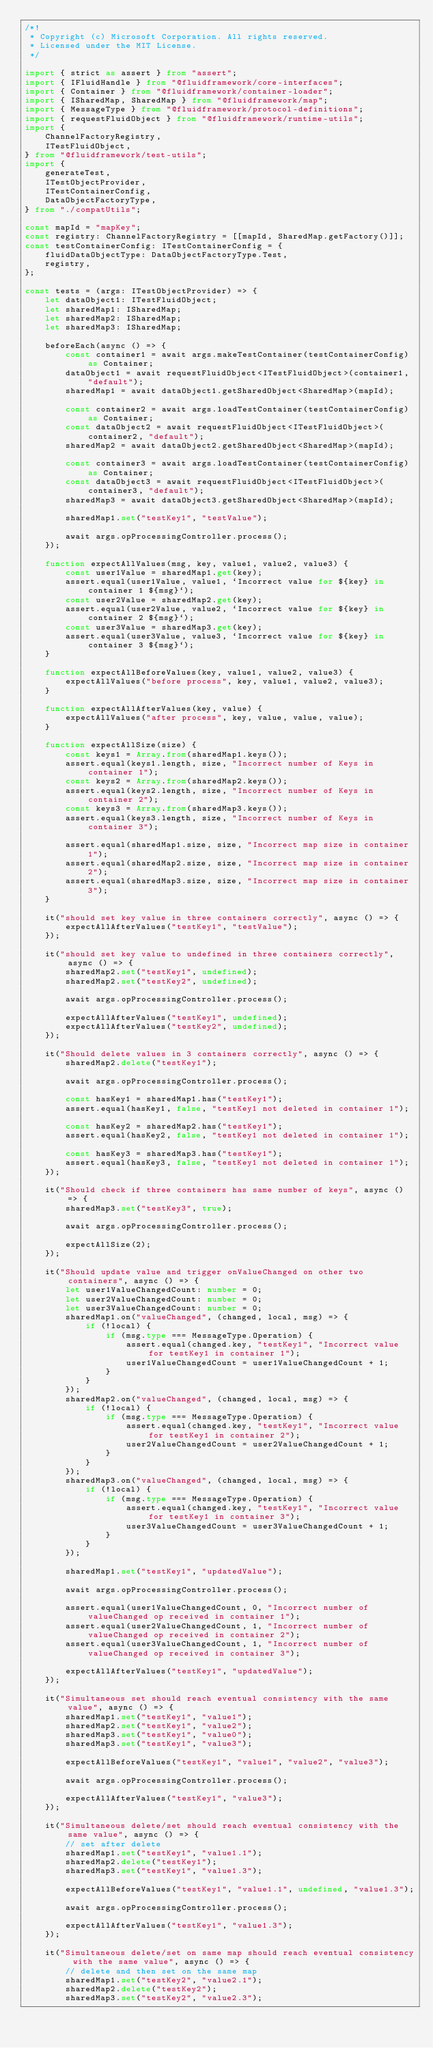Convert code to text. <code><loc_0><loc_0><loc_500><loc_500><_TypeScript_>/*!
 * Copyright (c) Microsoft Corporation. All rights reserved.
 * Licensed under the MIT License.
 */

import { strict as assert } from "assert";
import { IFluidHandle } from "@fluidframework/core-interfaces";
import { Container } from "@fluidframework/container-loader";
import { ISharedMap, SharedMap } from "@fluidframework/map";
import { MessageType } from "@fluidframework/protocol-definitions";
import { requestFluidObject } from "@fluidframework/runtime-utils";
import {
    ChannelFactoryRegistry,
    ITestFluidObject,
} from "@fluidframework/test-utils";
import {
    generateTest,
    ITestObjectProvider,
    ITestContainerConfig,
    DataObjectFactoryType,
} from "./compatUtils";

const mapId = "mapKey";
const registry: ChannelFactoryRegistry = [[mapId, SharedMap.getFactory()]];
const testContainerConfig: ITestContainerConfig = {
    fluidDataObjectType: DataObjectFactoryType.Test,
    registry,
};

const tests = (args: ITestObjectProvider) => {
    let dataObject1: ITestFluidObject;
    let sharedMap1: ISharedMap;
    let sharedMap2: ISharedMap;
    let sharedMap3: ISharedMap;

    beforeEach(async () => {
        const container1 = await args.makeTestContainer(testContainerConfig) as Container;
        dataObject1 = await requestFluidObject<ITestFluidObject>(container1, "default");
        sharedMap1 = await dataObject1.getSharedObject<SharedMap>(mapId);

        const container2 = await args.loadTestContainer(testContainerConfig) as Container;
        const dataObject2 = await requestFluidObject<ITestFluidObject>(container2, "default");
        sharedMap2 = await dataObject2.getSharedObject<SharedMap>(mapId);

        const container3 = await args.loadTestContainer(testContainerConfig) as Container;
        const dataObject3 = await requestFluidObject<ITestFluidObject>(container3, "default");
        sharedMap3 = await dataObject3.getSharedObject<SharedMap>(mapId);

        sharedMap1.set("testKey1", "testValue");

        await args.opProcessingController.process();
    });

    function expectAllValues(msg, key, value1, value2, value3) {
        const user1Value = sharedMap1.get(key);
        assert.equal(user1Value, value1, `Incorrect value for ${key} in container 1 ${msg}`);
        const user2Value = sharedMap2.get(key);
        assert.equal(user2Value, value2, `Incorrect value for ${key} in container 2 ${msg}`);
        const user3Value = sharedMap3.get(key);
        assert.equal(user3Value, value3, `Incorrect value for ${key} in container 3 ${msg}`);
    }

    function expectAllBeforeValues(key, value1, value2, value3) {
        expectAllValues("before process", key, value1, value2, value3);
    }

    function expectAllAfterValues(key, value) {
        expectAllValues("after process", key, value, value, value);
    }

    function expectAllSize(size) {
        const keys1 = Array.from(sharedMap1.keys());
        assert.equal(keys1.length, size, "Incorrect number of Keys in container 1");
        const keys2 = Array.from(sharedMap2.keys());
        assert.equal(keys2.length, size, "Incorrect number of Keys in container 2");
        const keys3 = Array.from(sharedMap3.keys());
        assert.equal(keys3.length, size, "Incorrect number of Keys in container 3");

        assert.equal(sharedMap1.size, size, "Incorrect map size in container 1");
        assert.equal(sharedMap2.size, size, "Incorrect map size in container 2");
        assert.equal(sharedMap3.size, size, "Incorrect map size in container 3");
    }

    it("should set key value in three containers correctly", async () => {
        expectAllAfterValues("testKey1", "testValue");
    });

    it("should set key value to undefined in three containers correctly", async () => {
        sharedMap2.set("testKey1", undefined);
        sharedMap2.set("testKey2", undefined);

        await args.opProcessingController.process();

        expectAllAfterValues("testKey1", undefined);
        expectAllAfterValues("testKey2", undefined);
    });

    it("Should delete values in 3 containers correctly", async () => {
        sharedMap2.delete("testKey1");

        await args.opProcessingController.process();

        const hasKey1 = sharedMap1.has("testKey1");
        assert.equal(hasKey1, false, "testKey1 not deleted in container 1");

        const hasKey2 = sharedMap2.has("testKey1");
        assert.equal(hasKey2, false, "testKey1 not deleted in container 1");

        const hasKey3 = sharedMap3.has("testKey1");
        assert.equal(hasKey3, false, "testKey1 not deleted in container 1");
    });

    it("Should check if three containers has same number of keys", async () => {
        sharedMap3.set("testKey3", true);

        await args.opProcessingController.process();

        expectAllSize(2);
    });

    it("Should update value and trigger onValueChanged on other two containers", async () => {
        let user1ValueChangedCount: number = 0;
        let user2ValueChangedCount: number = 0;
        let user3ValueChangedCount: number = 0;
        sharedMap1.on("valueChanged", (changed, local, msg) => {
            if (!local) {
                if (msg.type === MessageType.Operation) {
                    assert.equal(changed.key, "testKey1", "Incorrect value for testKey1 in container 1");
                    user1ValueChangedCount = user1ValueChangedCount + 1;
                }
            }
        });
        sharedMap2.on("valueChanged", (changed, local, msg) => {
            if (!local) {
                if (msg.type === MessageType.Operation) {
                    assert.equal(changed.key, "testKey1", "Incorrect value for testKey1 in container 2");
                    user2ValueChangedCount = user2ValueChangedCount + 1;
                }
            }
        });
        sharedMap3.on("valueChanged", (changed, local, msg) => {
            if (!local) {
                if (msg.type === MessageType.Operation) {
                    assert.equal(changed.key, "testKey1", "Incorrect value for testKey1 in container 3");
                    user3ValueChangedCount = user3ValueChangedCount + 1;
                }
            }
        });

        sharedMap1.set("testKey1", "updatedValue");

        await args.opProcessingController.process();

        assert.equal(user1ValueChangedCount, 0, "Incorrect number of valueChanged op received in container 1");
        assert.equal(user2ValueChangedCount, 1, "Incorrect number of valueChanged op received in container 2");
        assert.equal(user3ValueChangedCount, 1, "Incorrect number of valueChanged op received in container 3");

        expectAllAfterValues("testKey1", "updatedValue");
    });

    it("Simultaneous set should reach eventual consistency with the same value", async () => {
        sharedMap1.set("testKey1", "value1");
        sharedMap2.set("testKey1", "value2");
        sharedMap3.set("testKey1", "value0");
        sharedMap3.set("testKey1", "value3");

        expectAllBeforeValues("testKey1", "value1", "value2", "value3");

        await args.opProcessingController.process();

        expectAllAfterValues("testKey1", "value3");
    });

    it("Simultaneous delete/set should reach eventual consistency with the same value", async () => {
        // set after delete
        sharedMap1.set("testKey1", "value1.1");
        sharedMap2.delete("testKey1");
        sharedMap3.set("testKey1", "value1.3");

        expectAllBeforeValues("testKey1", "value1.1", undefined, "value1.3");

        await args.opProcessingController.process();

        expectAllAfterValues("testKey1", "value1.3");
    });

    it("Simultaneous delete/set on same map should reach eventual consistency with the same value", async () => {
        // delete and then set on the same map
        sharedMap1.set("testKey2", "value2.1");
        sharedMap2.delete("testKey2");
        sharedMap3.set("testKey2", "value2.3");
</code> 